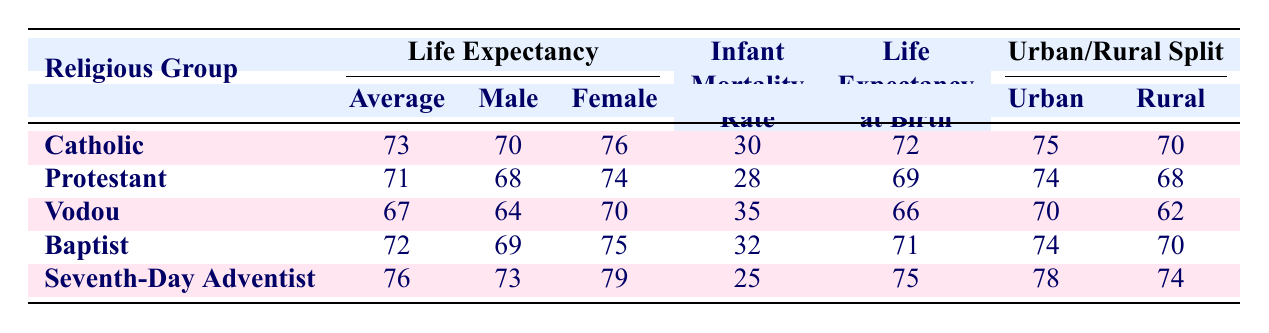What is the average life expectancy for the Seventh-Day Adventist community? The table indicates the average life expectancy for the Seventh-Day Adventist community is 76 years, listed under the "Average" column for that religious group.
Answer: 76 Which religious group has the highest infant mortality rate? According to the "Infant Mortality Rate" column, the Vodou community has the highest rate at 35.
Answer: Vodou What is the difference in average life expectancy between Catholics and Protestants? To find the difference, subtract the average life expectancy of Protestants (71) from that of Catholics (73): 73 - 71 = 2.
Answer: 2 Is the male life expectancy for Baptists higher than for Vodou adherents? The male life expectancy for Baptists is listed as 69, while for Vodou it's 64. Since 69 is greater than 64, the statement is true.
Answer: Yes What is the average life expectancy across all religious groups listed? Calculate the average by adding the average life expectancies: 73 (Catholic) + 71 (Protestant) + 67 (Vodou) + 72 (Baptist) + 76 (Seventh-Day Adventist) = 359. Then divide by 5 (the number of groups): 359 / 5 = 71.8.
Answer: 71.8 Which gender has a higher life expectancy in the Protestant community? By comparing the "Male Life Expectancy" (68) and "Female Life Expectancy" (74) for Protestants in the table, it's clear that females have a higher life expectancy than males.
Answer: Female For which group is the urban life expectancy greater than the rural life expectancy by the most significant margin? Analyzing the urban and rural splits, Catholics have an urban life expectancy of 75 and rural of 70, giving a difference of 5. Baptists show the same difference (74 urban, 70 rural) and Protestants have 6 (74 urban, 68 rural). Thus, Protestants have the largest margin.
Answer: Protestant What is the life expectancy at birth for the Vodou community? The table explicitly states that the life expectancy at birth for the Vodou community is 66.
Answer: 66 